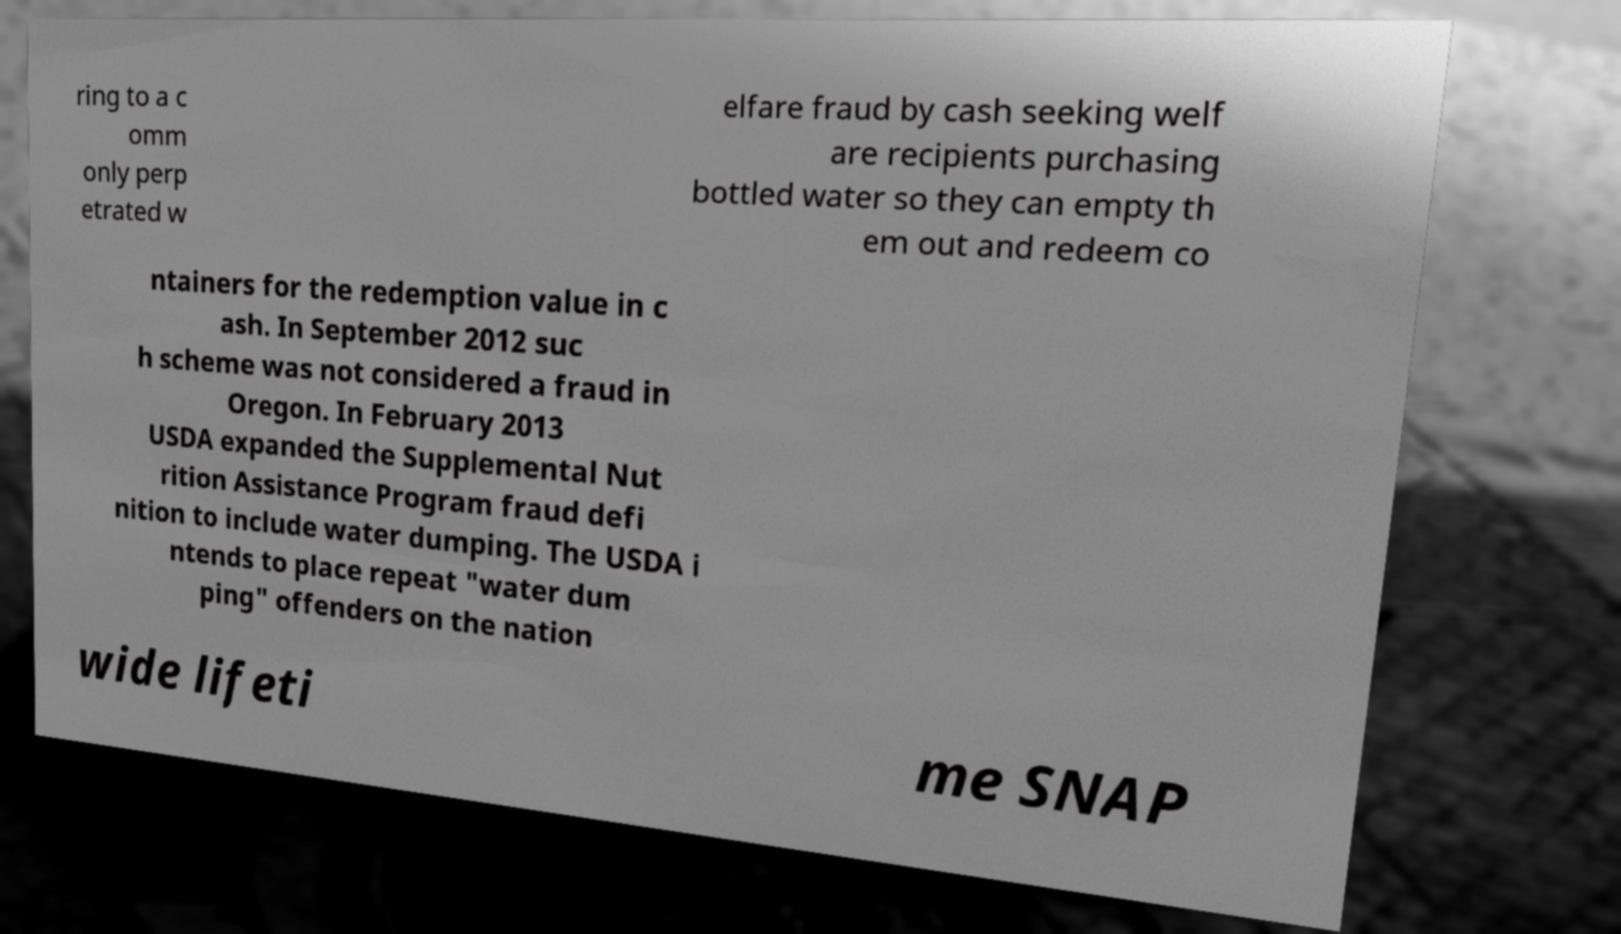There's text embedded in this image that I need extracted. Can you transcribe it verbatim? ring to a c omm only perp etrated w elfare fraud by cash seeking welf are recipients purchasing bottled water so they can empty th em out and redeem co ntainers for the redemption value in c ash. In September 2012 suc h scheme was not considered a fraud in Oregon. In February 2013 USDA expanded the Supplemental Nut rition Assistance Program fraud defi nition to include water dumping. The USDA i ntends to place repeat "water dum ping" offenders on the nation wide lifeti me SNAP 